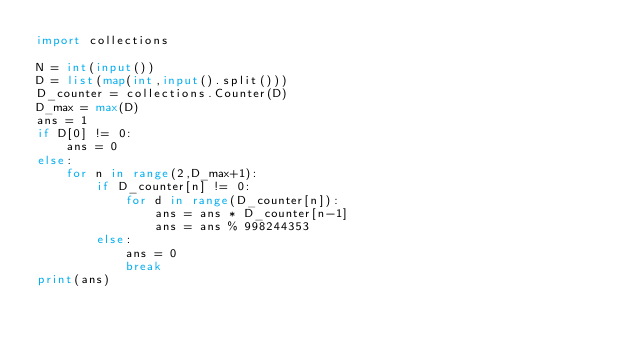<code> <loc_0><loc_0><loc_500><loc_500><_Python_>import collections

N = int(input())
D = list(map(int,input().split()))
D_counter = collections.Counter(D)
D_max = max(D)
ans = 1
if D[0] != 0:
    ans = 0
else:
    for n in range(2,D_max+1):
        if D_counter[n] != 0:
            for d in range(D_counter[n]):
                ans = ans * D_counter[n-1]
                ans = ans % 998244353
        else:
            ans = 0
            break
print(ans)
</code> 